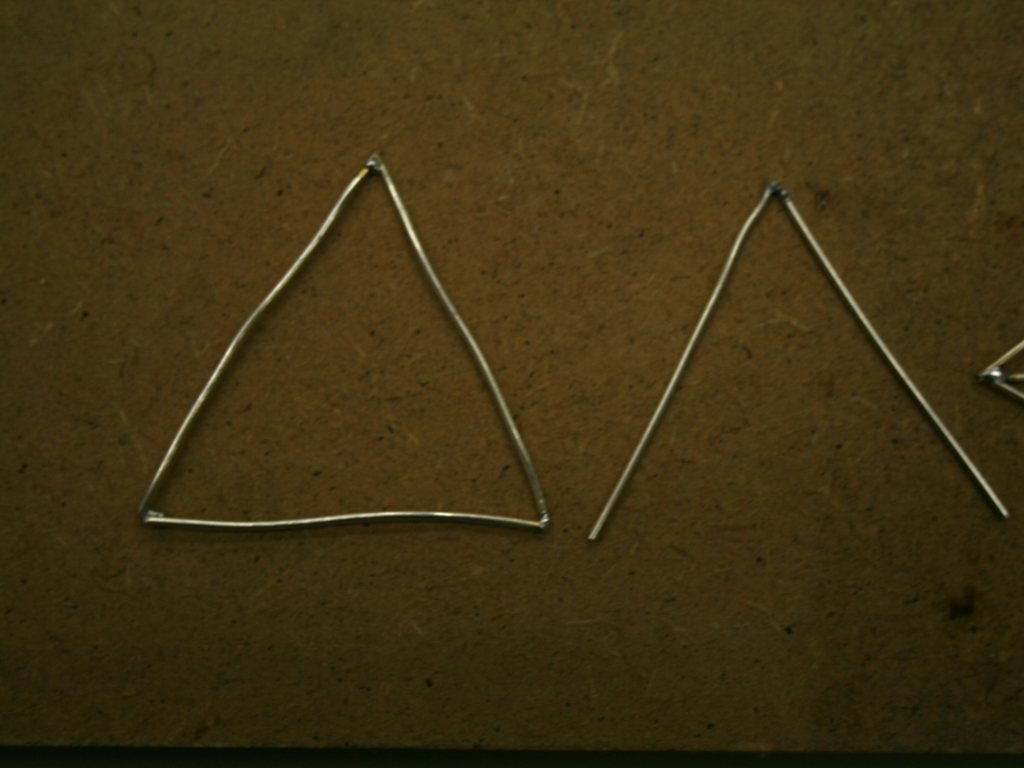Is there any indication of the size of these objects? Without a common object for scale, it's difficult to determine the exact size of the wireframe shapes. They could be quite small, like earrings, or larger, similar to decoration pieces. The texture of the surface they are on might give some context, but it remains ambiguous. 